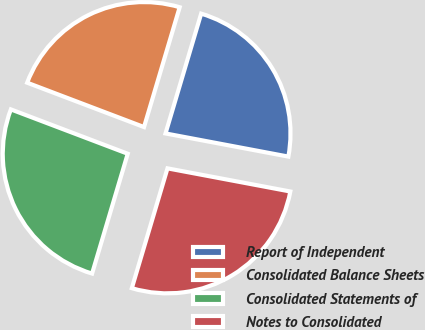Convert chart to OTSL. <chart><loc_0><loc_0><loc_500><loc_500><pie_chart><fcel>Report of Independent<fcel>Consolidated Balance Sheets<fcel>Consolidated Statements of<fcel>Notes to Consolidated<nl><fcel>23.36%<fcel>23.83%<fcel>26.17%<fcel>26.64%<nl></chart> 